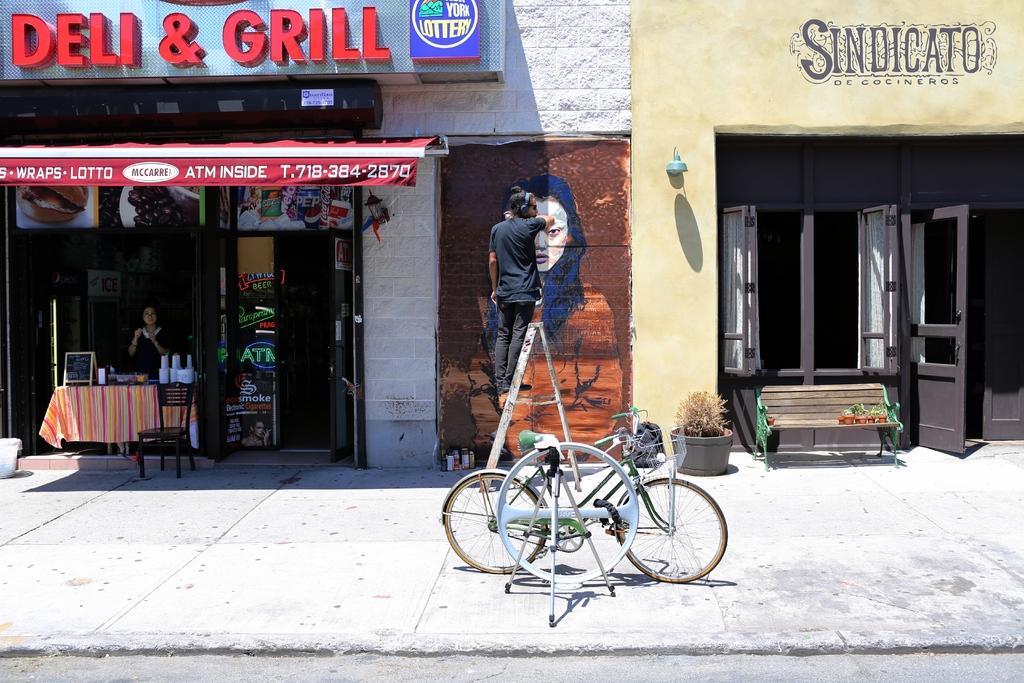Describe this image in one or two sentences. The person is standing on a stand and painting the wall and there are stores on the either side of him and there is a cycle park behind him. 